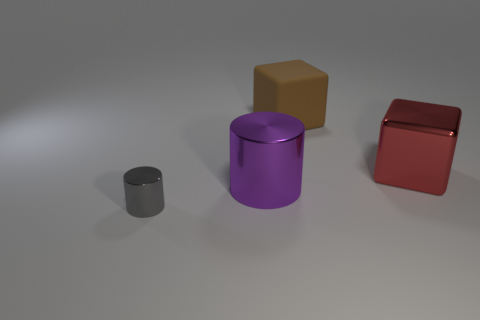Is the number of brown rubber things less than the number of tiny brown spheres?
Your answer should be very brief. No. What color is the shiny thing that is in front of the large purple thing?
Provide a succinct answer. Gray. What material is the thing that is to the right of the small cylinder and in front of the big red cube?
Offer a very short reply. Metal. There is another tiny thing that is made of the same material as the red thing; what is its shape?
Your response must be concise. Cylinder. How many large red shiny blocks are left of the large matte object that is behind the red metallic thing?
Give a very brief answer. 0. How many objects are both on the left side of the large purple cylinder and behind the large purple thing?
Keep it short and to the point. 0. What number of other things are the same material as the small cylinder?
Provide a succinct answer. 2. There is a large shiny thing that is to the right of the large metallic thing that is left of the rubber object; what is its color?
Offer a very short reply. Red. There is a big block that is in front of the rubber thing; is its color the same as the matte block?
Keep it short and to the point. No. Do the red object and the brown matte cube have the same size?
Give a very brief answer. Yes. 